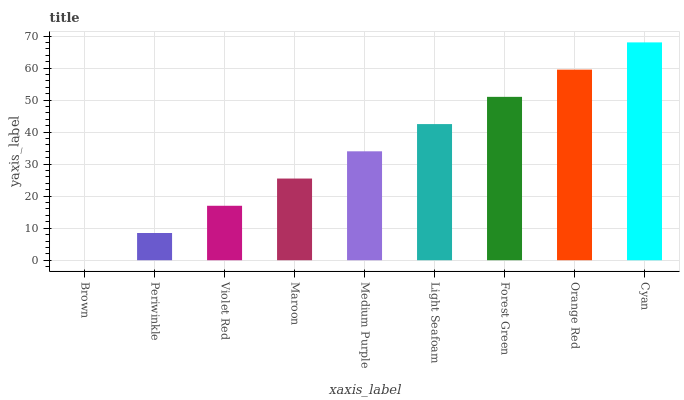Is Brown the minimum?
Answer yes or no. Yes. Is Cyan the maximum?
Answer yes or no. Yes. Is Periwinkle the minimum?
Answer yes or no. No. Is Periwinkle the maximum?
Answer yes or no. No. Is Periwinkle greater than Brown?
Answer yes or no. Yes. Is Brown less than Periwinkle?
Answer yes or no. Yes. Is Brown greater than Periwinkle?
Answer yes or no. No. Is Periwinkle less than Brown?
Answer yes or no. No. Is Medium Purple the high median?
Answer yes or no. Yes. Is Medium Purple the low median?
Answer yes or no. Yes. Is Violet Red the high median?
Answer yes or no. No. Is Brown the low median?
Answer yes or no. No. 